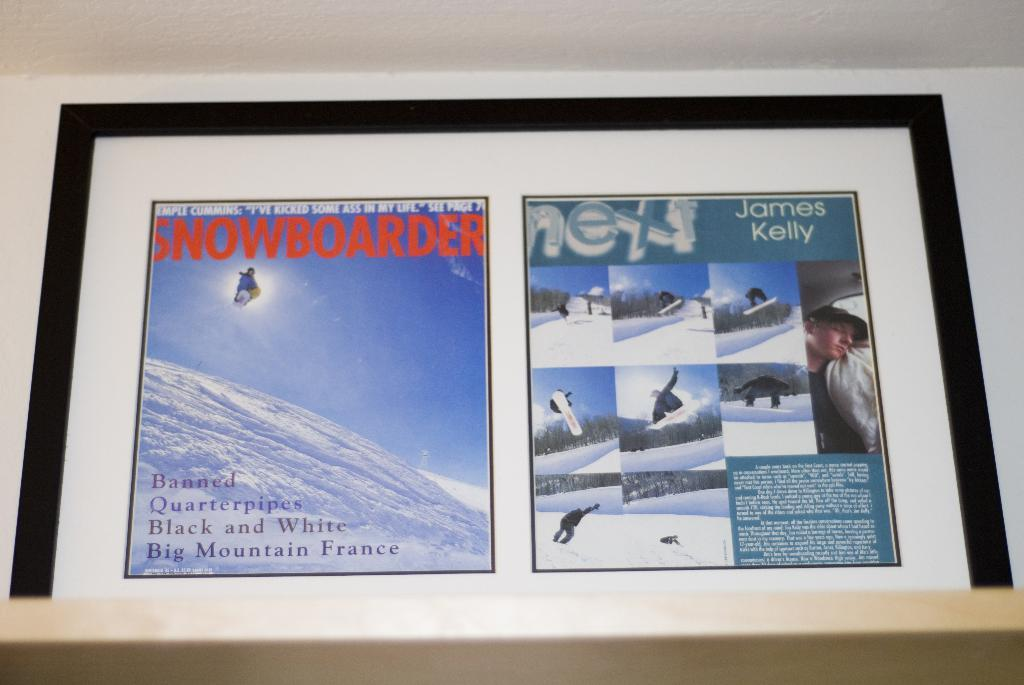<image>
Provide a brief description of the given image. A framed sports magazine cover and article. The magazine is titled Snowboarder and the article is about James Kelly. 